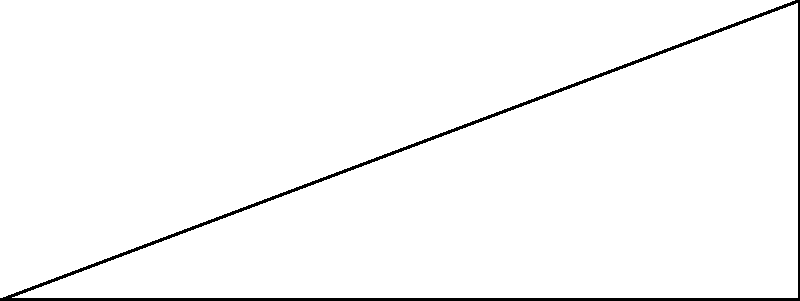As a driving enthusiast, you're testing your car's performance on a steep mountain road. Your 1500 kg car is climbing a 30° incline that's 10 meters long. Assuming the engine provides a constant force parallel to the incline and neglecting friction, how much work does the engine do to lift the car from the bottom to the top of the incline? Let's approach this step-by-step:

1) First, we need to calculate the vertical height (h) the car climbs:
   $h = 10 \sin(30°) = 5$ meters

2) The work done by the engine is equal to the change in potential energy of the car:
   $W = \Delta PE = mgh$

   Where:
   $m$ = mass of the car = 1500 kg
   $g$ = acceleration due to gravity = 9.8 m/s²
   $h$ = vertical height = 5 m

3) Plugging in these values:
   $W = 1500 \text{ kg} \times 9.8 \text{ m/s²} \times 5 \text{ m}$

4) Calculating:
   $W = 73,500 \text{ J}$

Therefore, the engine does 73,500 Joules of work to lift the car up the incline.
Answer: 73,500 J 